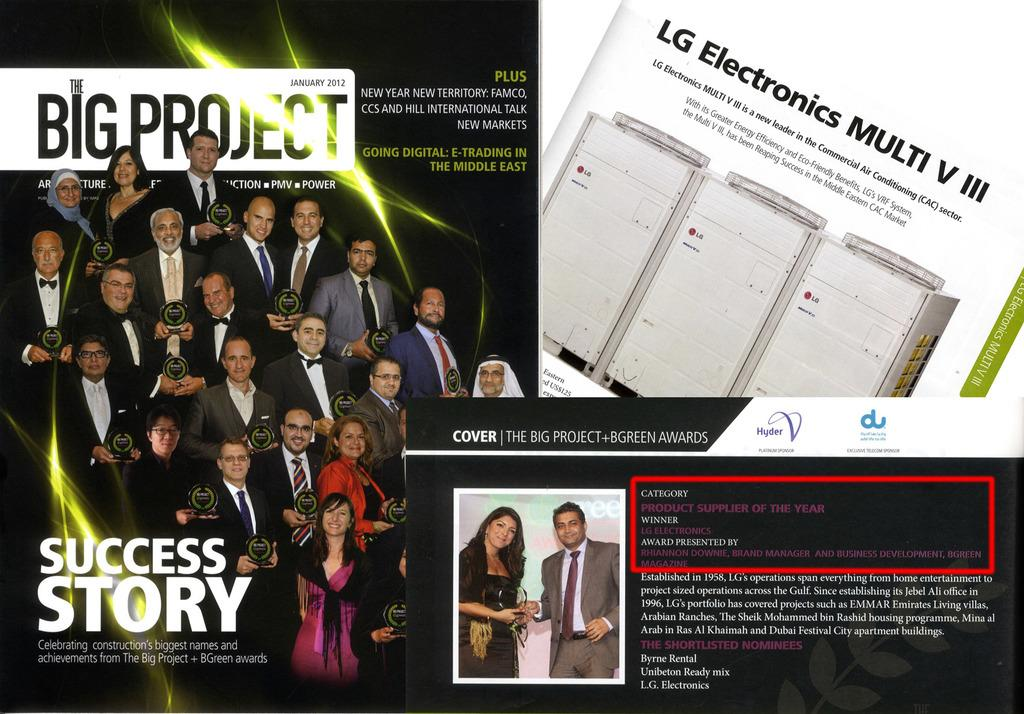Provide a one-sentence caption for the provided image. Big Project celebrates construction's biggest names and achievements. 